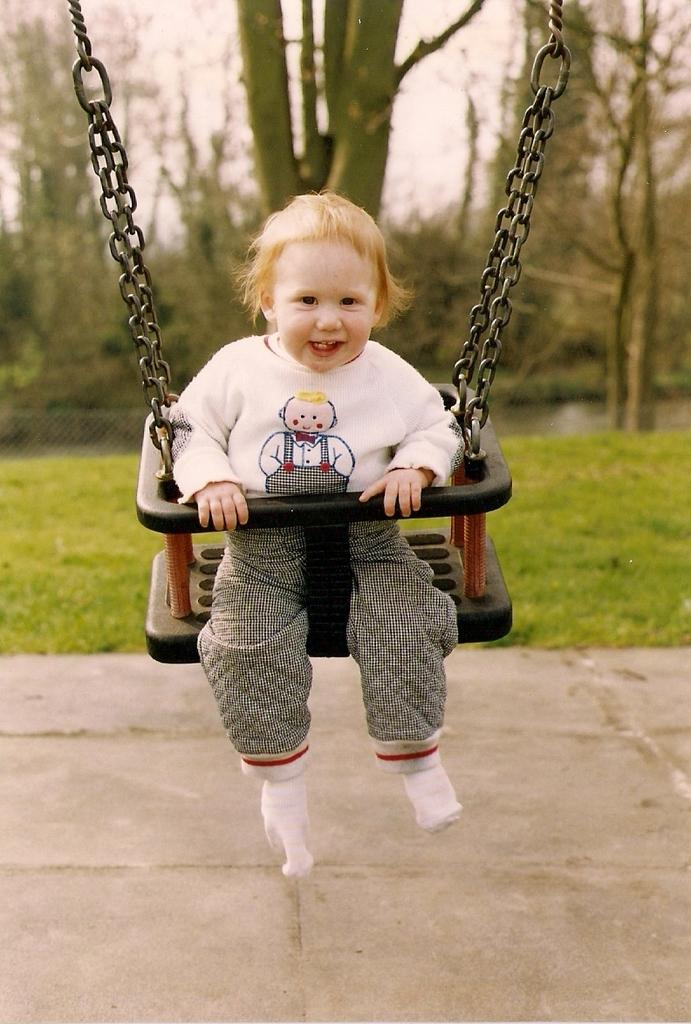What is the child doing in the image? The child is in a swing in the image. What type of surface is the child swinging on? There is grass visible in the image, which suggests the child is swinging on grass. What is the boundary of the area in the image? There is a fence in the image, which serves as the boundary. What type of vegetation can be seen in the image? There is a group of trees in the image. What is visible above the trees and fence in the image? The sky is visible in the image. What type of fuel is being used by the child in the swing? There is no fuel involved in the child's activity in the image; the child is simply swinging on a swing. What type of nut can be seen growing on the trees in the image? There is no mention of nuts or any specific type of tree in the image, so it cannot be determined if any nuts are present. 